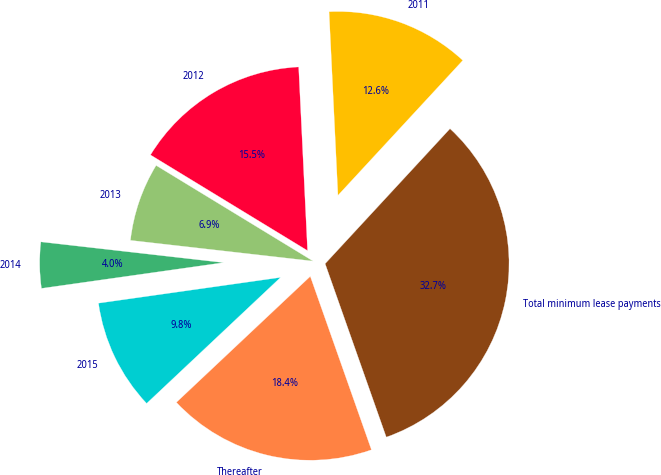Convert chart. <chart><loc_0><loc_0><loc_500><loc_500><pie_chart><fcel>2011<fcel>2012<fcel>2013<fcel>2014<fcel>2015<fcel>Thereafter<fcel>Total minimum lease payments<nl><fcel>12.65%<fcel>15.52%<fcel>6.91%<fcel>4.04%<fcel>9.78%<fcel>18.38%<fcel>32.73%<nl></chart> 